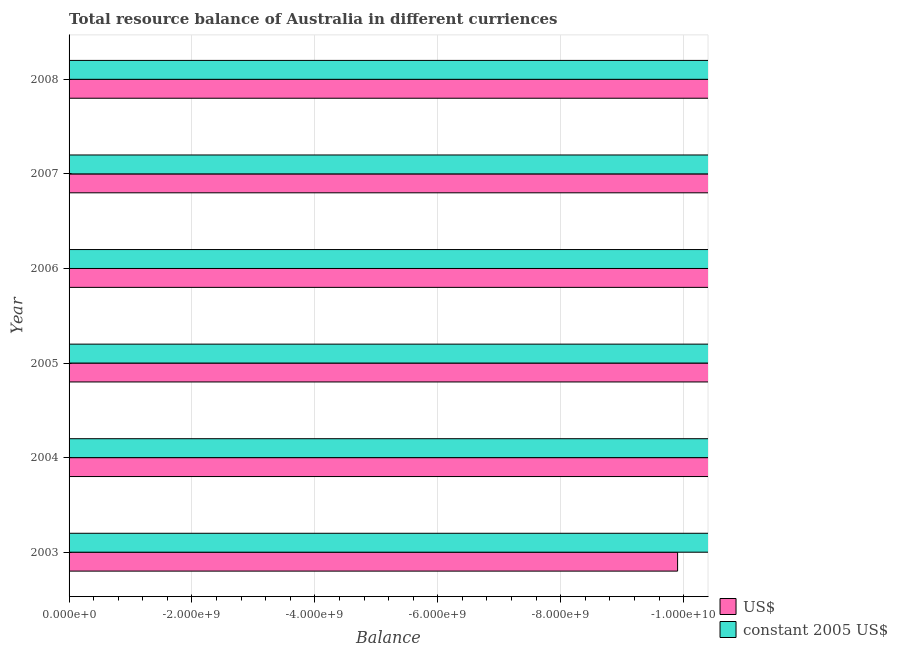How many different coloured bars are there?
Your answer should be compact. 0. Are the number of bars on each tick of the Y-axis equal?
Your answer should be very brief. Yes. How many bars are there on the 2nd tick from the top?
Your answer should be very brief. 0. In how many cases, is the number of bars for a given year not equal to the number of legend labels?
Your answer should be compact. 6. What is the resource balance in constant us$ in 2007?
Your answer should be compact. 0. Across all years, what is the minimum resource balance in us$?
Ensure brevity in your answer.  0. What is the average resource balance in us$ per year?
Make the answer very short. 0. How many bars are there?
Your answer should be compact. 0. What is the difference between two consecutive major ticks on the X-axis?
Provide a short and direct response. 2.00e+09. Are the values on the major ticks of X-axis written in scientific E-notation?
Make the answer very short. Yes. Does the graph contain any zero values?
Provide a short and direct response. Yes. Where does the legend appear in the graph?
Provide a short and direct response. Bottom right. What is the title of the graph?
Provide a short and direct response. Total resource balance of Australia in different curriences. Does "Travel services" appear as one of the legend labels in the graph?
Keep it short and to the point. No. What is the label or title of the X-axis?
Keep it short and to the point. Balance. What is the Balance in US$ in 2003?
Provide a short and direct response. 0. What is the Balance of US$ in 2004?
Provide a short and direct response. 0. What is the Balance in constant 2005 US$ in 2004?
Provide a short and direct response. 0. What is the Balance in US$ in 2005?
Make the answer very short. 0. What is the Balance of constant 2005 US$ in 2005?
Provide a short and direct response. 0. What is the Balance of US$ in 2008?
Keep it short and to the point. 0. What is the total Balance of constant 2005 US$ in the graph?
Your answer should be very brief. 0. What is the average Balance in US$ per year?
Your answer should be very brief. 0. What is the average Balance in constant 2005 US$ per year?
Ensure brevity in your answer.  0. 